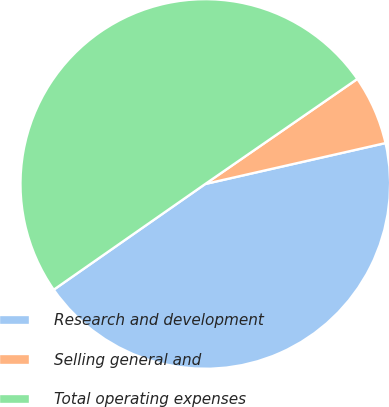Convert chart to OTSL. <chart><loc_0><loc_0><loc_500><loc_500><pie_chart><fcel>Research and development<fcel>Selling general and<fcel>Total operating expenses<nl><fcel>43.86%<fcel>6.07%<fcel>50.08%<nl></chart> 